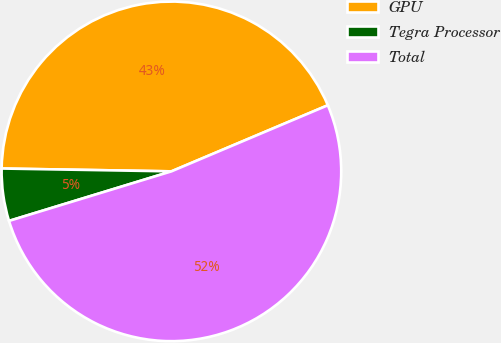Convert chart. <chart><loc_0><loc_0><loc_500><loc_500><pie_chart><fcel>GPU<fcel>Tegra Processor<fcel>Total<nl><fcel>43.37%<fcel>4.98%<fcel>51.65%<nl></chart> 